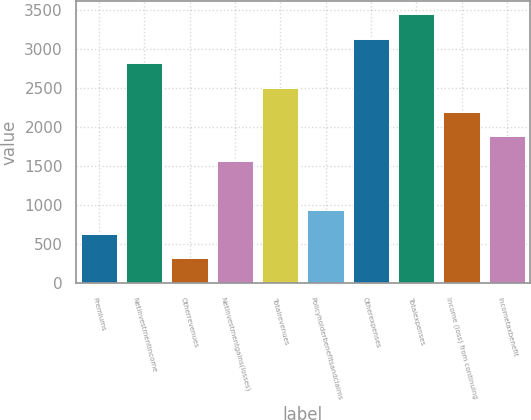Convert chart to OTSL. <chart><loc_0><loc_0><loc_500><loc_500><bar_chart><fcel>Premiums<fcel>Netinvestmentincome<fcel>Otherrevenues<fcel>Netinvestmentgains(losses)<fcel>Totalrevenues<fcel>Policyholderbenefitsandclaims<fcel>Otherexpenses<fcel>Totalexpenses<fcel>Income (loss) from continuing<fcel>Incometaxbenefit<nl><fcel>631.6<fcel>2821.2<fcel>318.8<fcel>1570<fcel>2508.4<fcel>944.4<fcel>3134<fcel>3446.8<fcel>2195.6<fcel>1882.8<nl></chart> 